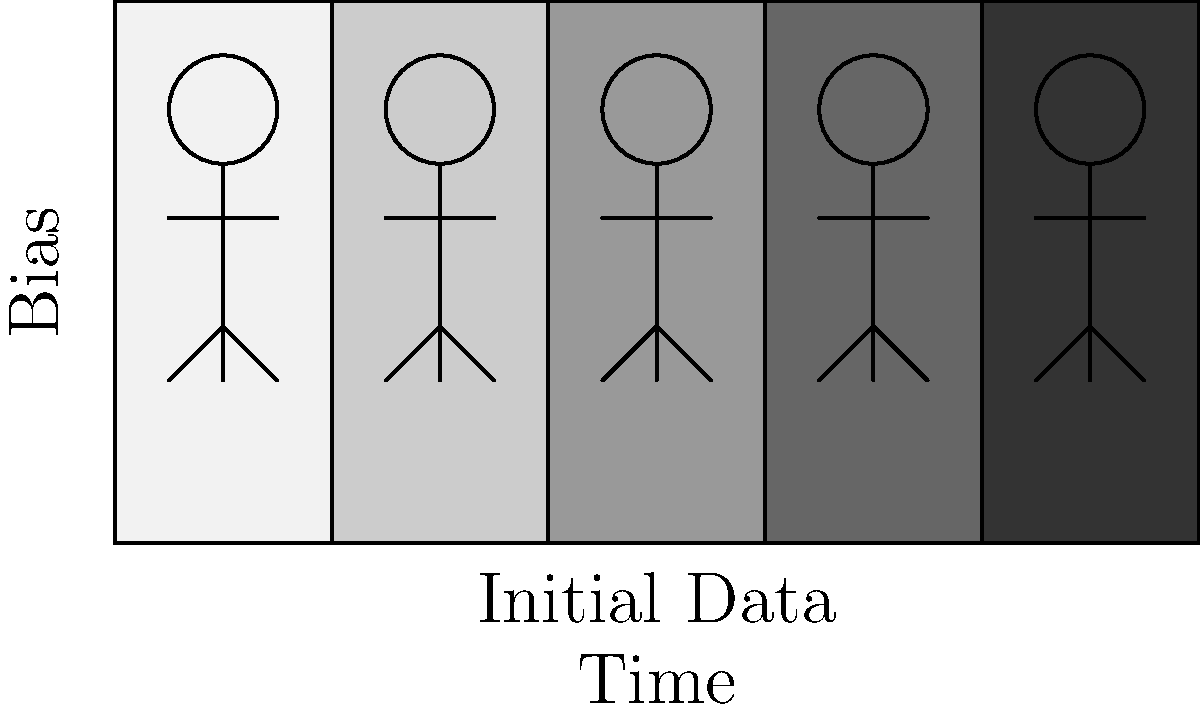As a software engineer concerned with the societal impact of code, analyze the sequence of images illustrating the progression of bias in machine learning models. What does the darkening of figures from left to right most likely represent in terms of model behavior over time? To answer this question, let's analyze the image step-by-step:

1. The image shows a sequence of five rectangles, each containing a stick figure.
2. The rectangles progress from light to dark from left to right.
3. The y-axis is labeled "Bias," suggesting that the vertical dimension represents the level of bias.
4. The x-axis is labeled "Time" and "Initial Data," indicating a progression over time starting from the initial dataset.

Given this information and the context of machine learning bias:

5. The darkening of figures likely represents an increase in bias over time.
6. This progression suggests that as the model continues to learn and make predictions, it's amplifying existing biases present in the initial data.
7. In machine learning, this phenomenon is known as "bias amplification" or "feedback loop."
8. The model's predictions influence future data collection or decision-making, which then reinforces and exacerbates the initial bias.
9. As a software engineer concerned with societal impact, this visualization highlights the importance of monitoring and mitigating bias throughout a model's lifecycle, not just at the initial training stage.

The darkening thus represents the model's increasing tendency to make biased decisions or predictions over time, potentially leading to more severe societal consequences if left unchecked.
Answer: Bias amplification over time 